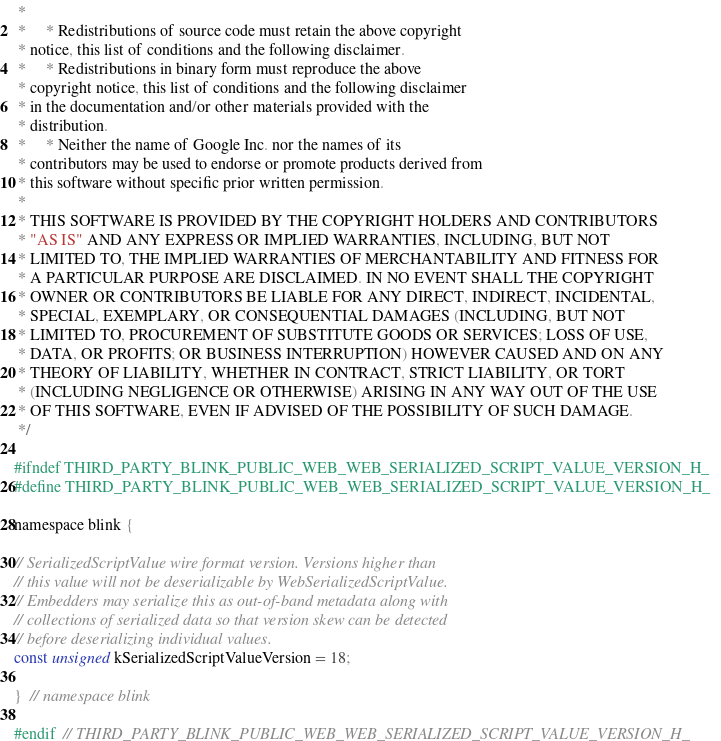Convert code to text. <code><loc_0><loc_0><loc_500><loc_500><_C_> *
 *     * Redistributions of source code must retain the above copyright
 * notice, this list of conditions and the following disclaimer.
 *     * Redistributions in binary form must reproduce the above
 * copyright notice, this list of conditions and the following disclaimer
 * in the documentation and/or other materials provided with the
 * distribution.
 *     * Neither the name of Google Inc. nor the names of its
 * contributors may be used to endorse or promote products derived from
 * this software without specific prior written permission.
 *
 * THIS SOFTWARE IS PROVIDED BY THE COPYRIGHT HOLDERS AND CONTRIBUTORS
 * "AS IS" AND ANY EXPRESS OR IMPLIED WARRANTIES, INCLUDING, BUT NOT
 * LIMITED TO, THE IMPLIED WARRANTIES OF MERCHANTABILITY AND FITNESS FOR
 * A PARTICULAR PURPOSE ARE DISCLAIMED. IN NO EVENT SHALL THE COPYRIGHT
 * OWNER OR CONTRIBUTORS BE LIABLE FOR ANY DIRECT, INDIRECT, INCIDENTAL,
 * SPECIAL, EXEMPLARY, OR CONSEQUENTIAL DAMAGES (INCLUDING, BUT NOT
 * LIMITED TO, PROCUREMENT OF SUBSTITUTE GOODS OR SERVICES; LOSS OF USE,
 * DATA, OR PROFITS; OR BUSINESS INTERRUPTION) HOWEVER CAUSED AND ON ANY
 * THEORY OF LIABILITY, WHETHER IN CONTRACT, STRICT LIABILITY, OR TORT
 * (INCLUDING NEGLIGENCE OR OTHERWISE) ARISING IN ANY WAY OUT OF THE USE
 * OF THIS SOFTWARE, EVEN IF ADVISED OF THE POSSIBILITY OF SUCH DAMAGE.
 */

#ifndef THIRD_PARTY_BLINK_PUBLIC_WEB_WEB_SERIALIZED_SCRIPT_VALUE_VERSION_H_
#define THIRD_PARTY_BLINK_PUBLIC_WEB_WEB_SERIALIZED_SCRIPT_VALUE_VERSION_H_

namespace blink {

// SerializedScriptValue wire format version. Versions higher than
// this value will not be deserializable by WebSerializedScriptValue.
// Embedders may serialize this as out-of-band metadata along with
// collections of serialized data so that version skew can be detected
// before deserializing individual values.
const unsigned kSerializedScriptValueVersion = 18;

}  // namespace blink

#endif  // THIRD_PARTY_BLINK_PUBLIC_WEB_WEB_SERIALIZED_SCRIPT_VALUE_VERSION_H_
</code> 